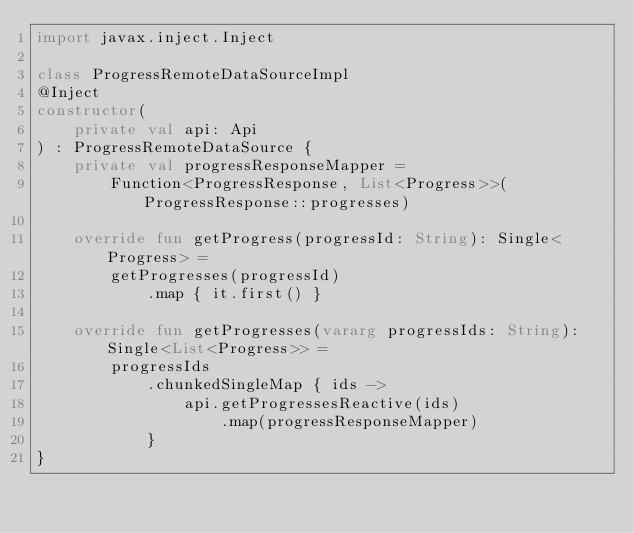<code> <loc_0><loc_0><loc_500><loc_500><_Kotlin_>import javax.inject.Inject

class ProgressRemoteDataSourceImpl
@Inject
constructor(
    private val api: Api
) : ProgressRemoteDataSource {
    private val progressResponseMapper =
        Function<ProgressResponse, List<Progress>>(ProgressResponse::progresses)

    override fun getProgress(progressId: String): Single<Progress> =
        getProgresses(progressId)
            .map { it.first() }

    override fun getProgresses(vararg progressIds: String): Single<List<Progress>> =
        progressIds
            .chunkedSingleMap { ids ->
                api.getProgressesReactive(ids)
                    .map(progressResponseMapper)
            }
}</code> 